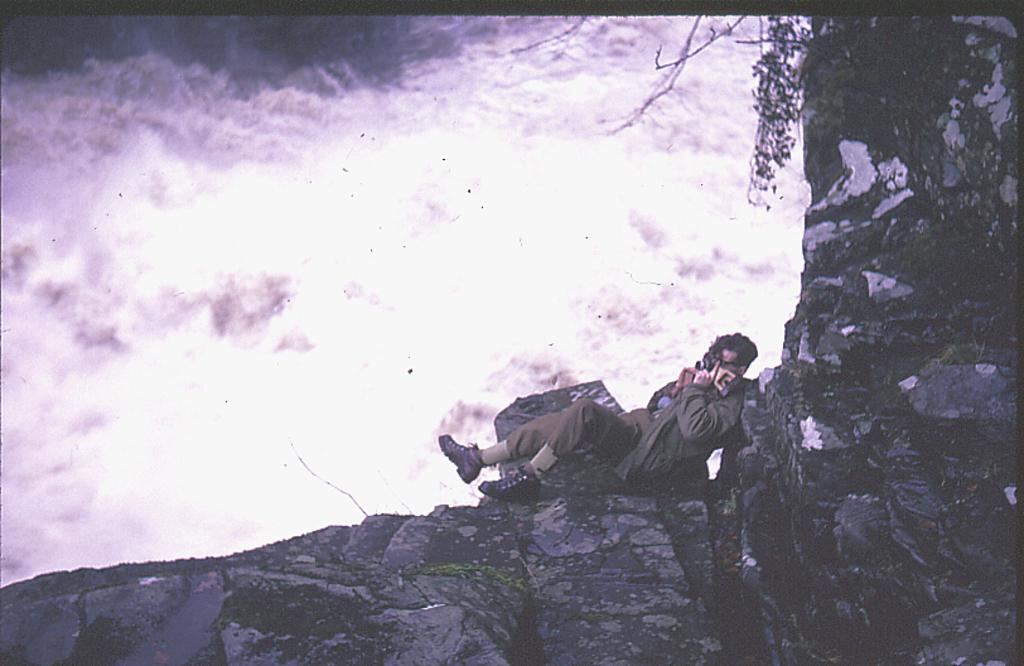What can be observed about the image's appearance? The image appears to be edited. What can be seen in the foreground and towards the right? There are rocks, a plant, and a person in the foreground and towards the right. What is visible at the top and towards the left? There are clouds at the top and towards the left. Where is the sister's tent located in the image? There is no sister or tent present in the image. What type of apparatus is being used by the person in the image? The image does not show any apparatus being used by the person; they are simply standing in the foreground. 